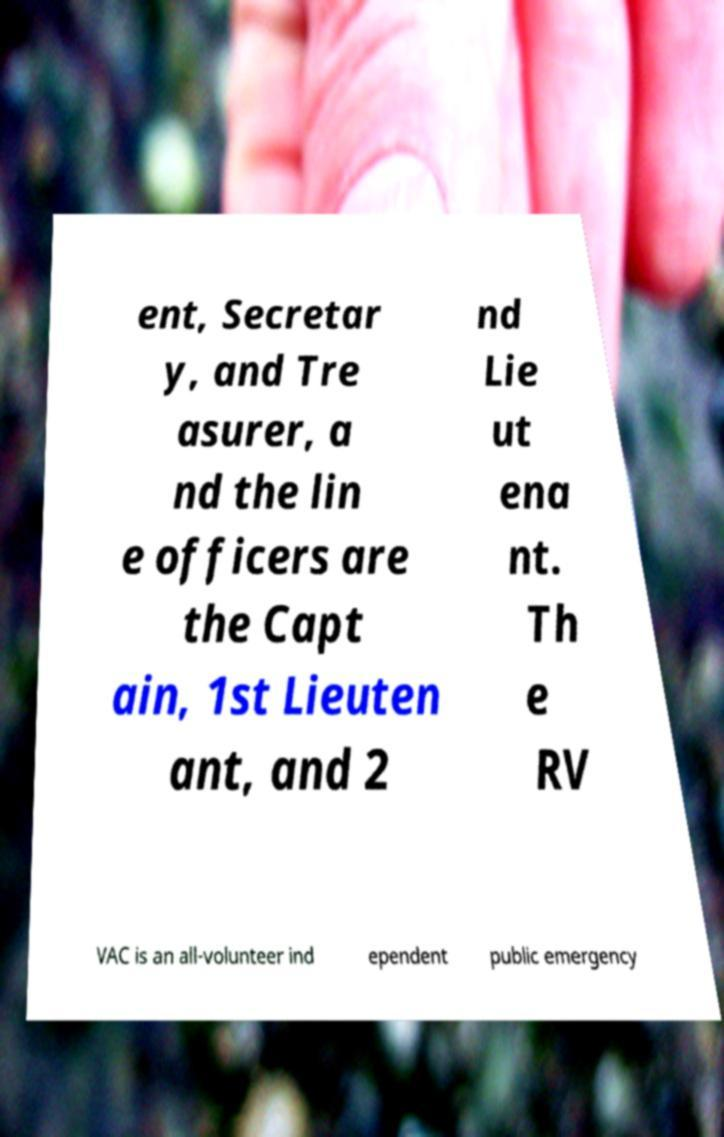Please read and relay the text visible in this image. What does it say? ent, Secretar y, and Tre asurer, a nd the lin e officers are the Capt ain, 1st Lieuten ant, and 2 nd Lie ut ena nt. Th e RV VAC is an all-volunteer ind ependent public emergency 